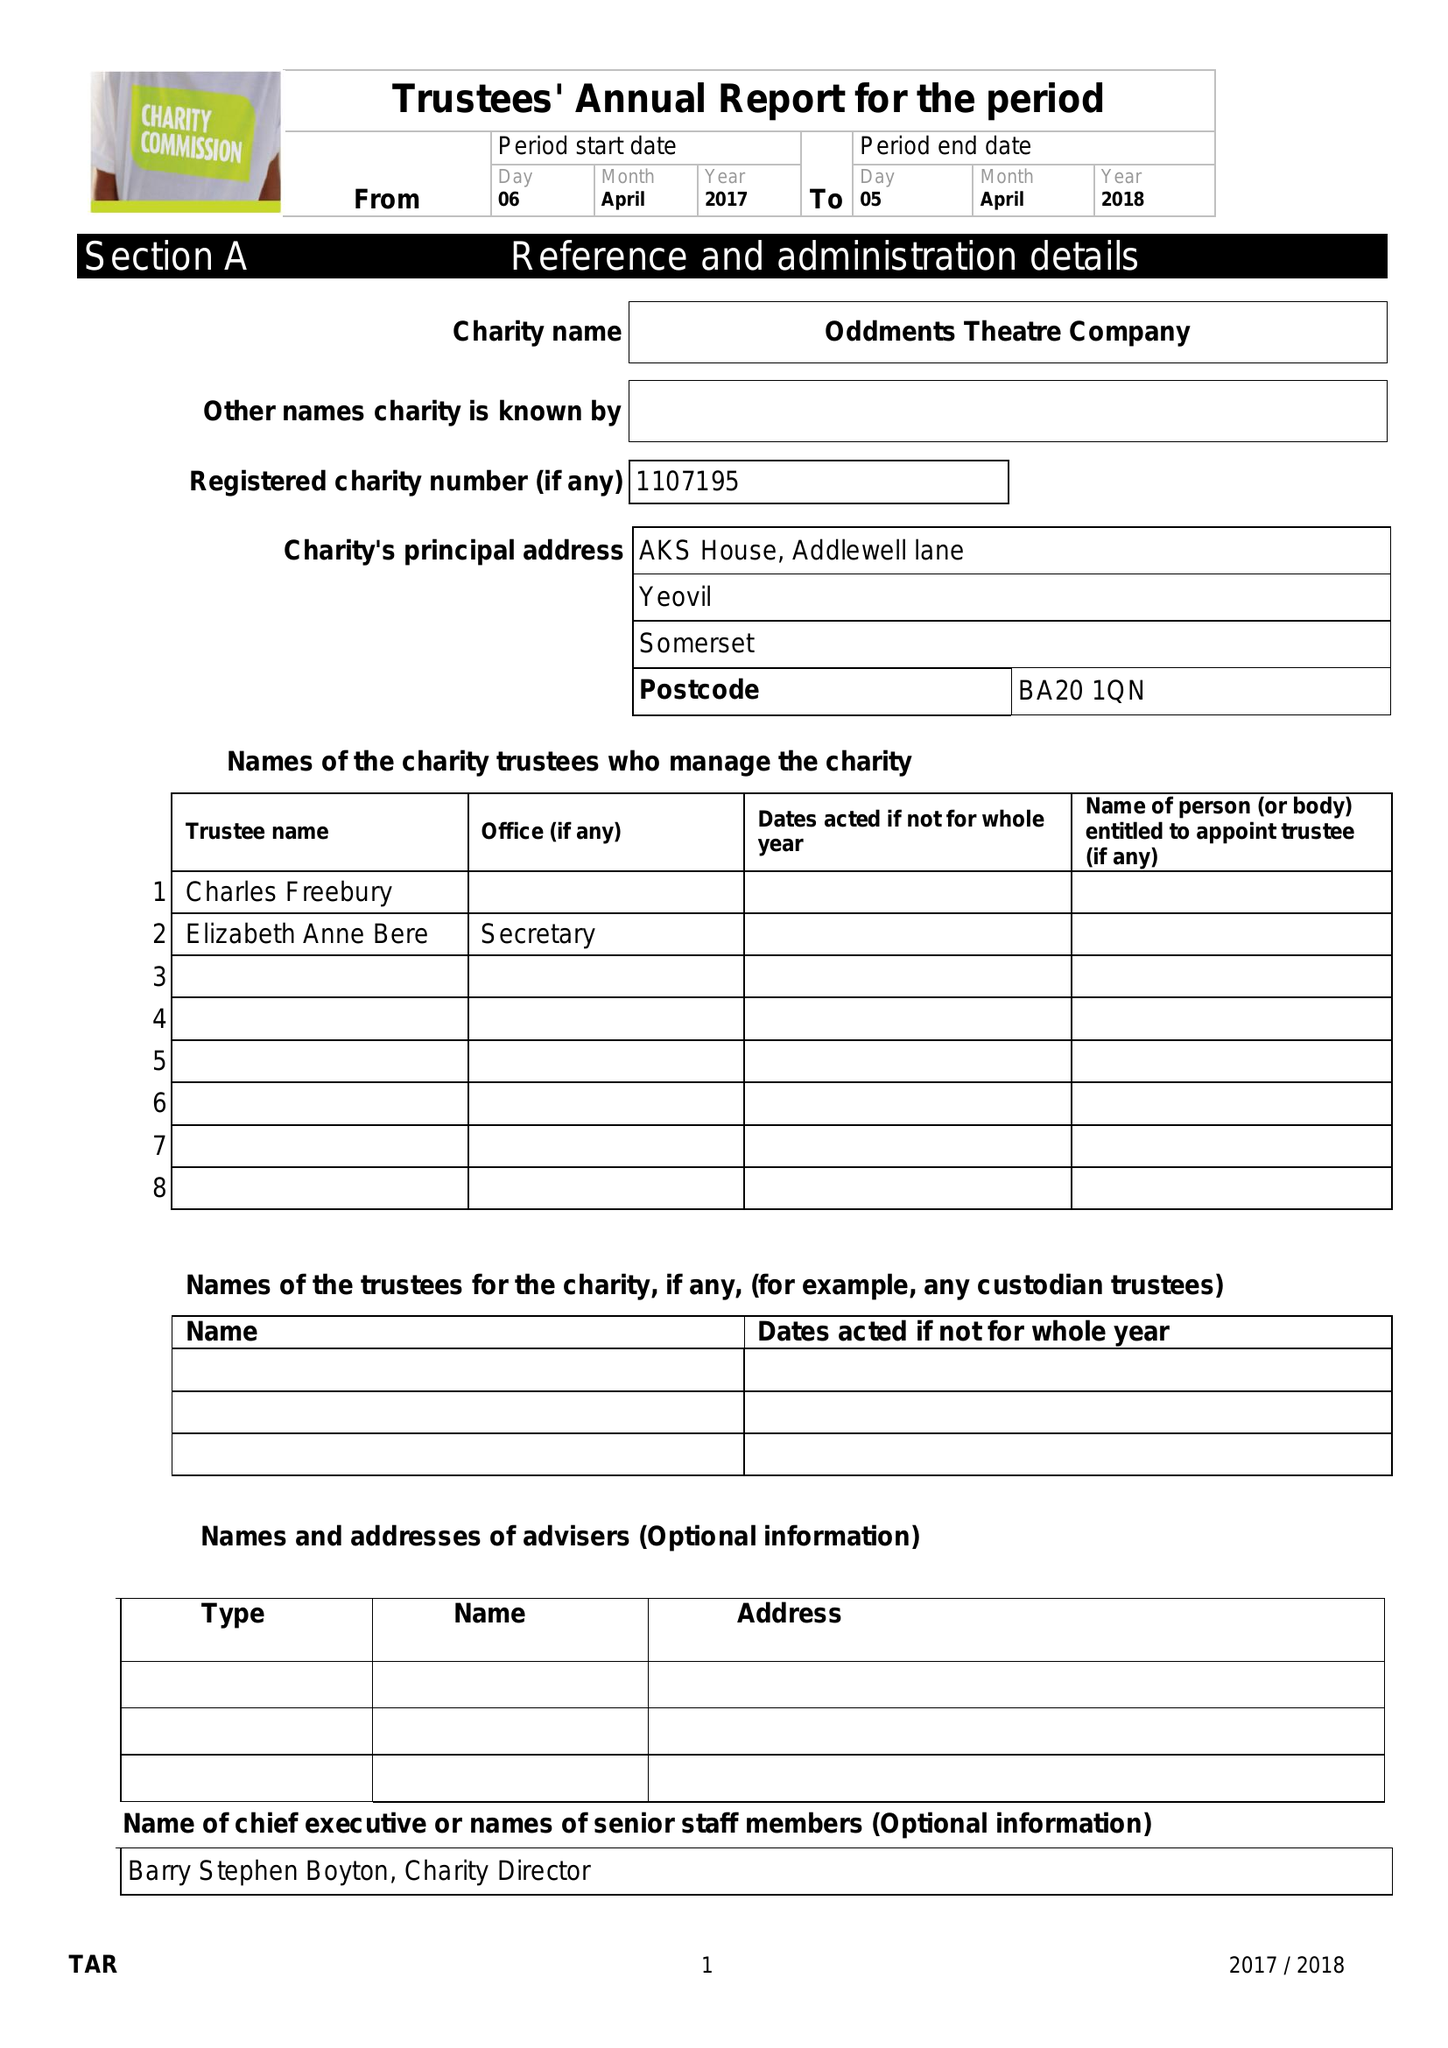What is the value for the charity_number?
Answer the question using a single word or phrase. 1107195 